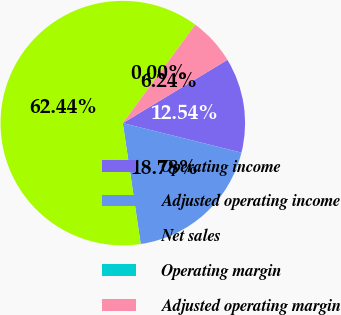Convert chart. <chart><loc_0><loc_0><loc_500><loc_500><pie_chart><fcel>Operating income<fcel>Adjusted operating income<fcel>Net sales<fcel>Operating margin<fcel>Adjusted operating margin<nl><fcel>12.54%<fcel>18.78%<fcel>62.44%<fcel>0.0%<fcel>6.24%<nl></chart> 